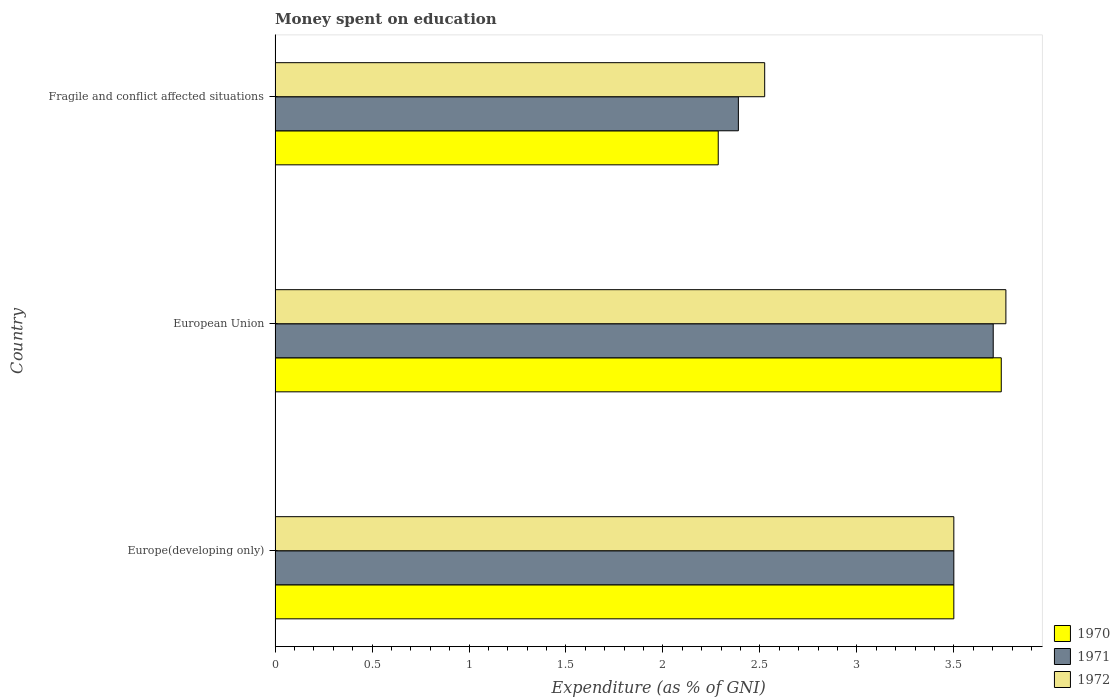How many different coloured bars are there?
Your answer should be compact. 3. How many groups of bars are there?
Your answer should be compact. 3. How many bars are there on the 1st tick from the top?
Give a very brief answer. 3. What is the label of the 1st group of bars from the top?
Give a very brief answer. Fragile and conflict affected situations. What is the amount of money spent on education in 1970 in European Union?
Ensure brevity in your answer.  3.74. Across all countries, what is the maximum amount of money spent on education in 1971?
Make the answer very short. 3.7. Across all countries, what is the minimum amount of money spent on education in 1970?
Offer a terse response. 2.29. In which country was the amount of money spent on education in 1970 maximum?
Your answer should be compact. European Union. In which country was the amount of money spent on education in 1972 minimum?
Provide a short and direct response. Fragile and conflict affected situations. What is the total amount of money spent on education in 1972 in the graph?
Your answer should be compact. 9.79. What is the difference between the amount of money spent on education in 1971 in European Union and that in Fragile and conflict affected situations?
Your answer should be very brief. 1.31. What is the difference between the amount of money spent on education in 1971 in European Union and the amount of money spent on education in 1972 in Fragile and conflict affected situations?
Your answer should be compact. 1.18. What is the average amount of money spent on education in 1972 per country?
Provide a succinct answer. 3.26. What is the difference between the amount of money spent on education in 1971 and amount of money spent on education in 1970 in Fragile and conflict affected situations?
Offer a terse response. 0.1. In how many countries, is the amount of money spent on education in 1970 greater than 3.6 %?
Provide a succinct answer. 1. What is the ratio of the amount of money spent on education in 1970 in European Union to that in Fragile and conflict affected situations?
Provide a succinct answer. 1.64. Is the amount of money spent on education in 1971 in Europe(developing only) less than that in European Union?
Your answer should be very brief. Yes. Is the difference between the amount of money spent on education in 1971 in Europe(developing only) and Fragile and conflict affected situations greater than the difference between the amount of money spent on education in 1970 in Europe(developing only) and Fragile and conflict affected situations?
Make the answer very short. No. What is the difference between the highest and the second highest amount of money spent on education in 1970?
Your response must be concise. 0.24. What is the difference between the highest and the lowest amount of money spent on education in 1971?
Ensure brevity in your answer.  1.31. What does the 3rd bar from the bottom in Fragile and conflict affected situations represents?
Ensure brevity in your answer.  1972. How many bars are there?
Keep it short and to the point. 9. Are all the bars in the graph horizontal?
Make the answer very short. Yes. How many countries are there in the graph?
Your answer should be very brief. 3. Are the values on the major ticks of X-axis written in scientific E-notation?
Keep it short and to the point. No. Where does the legend appear in the graph?
Offer a terse response. Bottom right. How many legend labels are there?
Give a very brief answer. 3. What is the title of the graph?
Provide a succinct answer. Money spent on education. What is the label or title of the X-axis?
Make the answer very short. Expenditure (as % of GNI). What is the Expenditure (as % of GNI) in 1972 in Europe(developing only)?
Offer a terse response. 3.5. What is the Expenditure (as % of GNI) of 1970 in European Union?
Provide a succinct answer. 3.74. What is the Expenditure (as % of GNI) in 1971 in European Union?
Give a very brief answer. 3.7. What is the Expenditure (as % of GNI) in 1972 in European Union?
Give a very brief answer. 3.77. What is the Expenditure (as % of GNI) in 1970 in Fragile and conflict affected situations?
Your answer should be very brief. 2.29. What is the Expenditure (as % of GNI) in 1971 in Fragile and conflict affected situations?
Offer a very short reply. 2.39. What is the Expenditure (as % of GNI) of 1972 in Fragile and conflict affected situations?
Your answer should be very brief. 2.52. Across all countries, what is the maximum Expenditure (as % of GNI) of 1970?
Offer a terse response. 3.74. Across all countries, what is the maximum Expenditure (as % of GNI) of 1971?
Your answer should be compact. 3.7. Across all countries, what is the maximum Expenditure (as % of GNI) in 1972?
Give a very brief answer. 3.77. Across all countries, what is the minimum Expenditure (as % of GNI) of 1970?
Keep it short and to the point. 2.29. Across all countries, what is the minimum Expenditure (as % of GNI) of 1971?
Your response must be concise. 2.39. Across all countries, what is the minimum Expenditure (as % of GNI) in 1972?
Keep it short and to the point. 2.52. What is the total Expenditure (as % of GNI) in 1970 in the graph?
Keep it short and to the point. 9.53. What is the total Expenditure (as % of GNI) in 1971 in the graph?
Your answer should be compact. 9.59. What is the total Expenditure (as % of GNI) in 1972 in the graph?
Ensure brevity in your answer.  9.79. What is the difference between the Expenditure (as % of GNI) of 1970 in Europe(developing only) and that in European Union?
Offer a terse response. -0.24. What is the difference between the Expenditure (as % of GNI) of 1971 in Europe(developing only) and that in European Union?
Your answer should be compact. -0.2. What is the difference between the Expenditure (as % of GNI) in 1972 in Europe(developing only) and that in European Union?
Give a very brief answer. -0.27. What is the difference between the Expenditure (as % of GNI) in 1970 in Europe(developing only) and that in Fragile and conflict affected situations?
Keep it short and to the point. 1.21. What is the difference between the Expenditure (as % of GNI) in 1971 in Europe(developing only) and that in Fragile and conflict affected situations?
Give a very brief answer. 1.11. What is the difference between the Expenditure (as % of GNI) of 1972 in Europe(developing only) and that in Fragile and conflict affected situations?
Ensure brevity in your answer.  0.98. What is the difference between the Expenditure (as % of GNI) in 1970 in European Union and that in Fragile and conflict affected situations?
Ensure brevity in your answer.  1.46. What is the difference between the Expenditure (as % of GNI) in 1971 in European Union and that in Fragile and conflict affected situations?
Offer a very short reply. 1.31. What is the difference between the Expenditure (as % of GNI) in 1972 in European Union and that in Fragile and conflict affected situations?
Your answer should be compact. 1.24. What is the difference between the Expenditure (as % of GNI) of 1970 in Europe(developing only) and the Expenditure (as % of GNI) of 1971 in European Union?
Your answer should be very brief. -0.2. What is the difference between the Expenditure (as % of GNI) of 1970 in Europe(developing only) and the Expenditure (as % of GNI) of 1972 in European Union?
Ensure brevity in your answer.  -0.27. What is the difference between the Expenditure (as % of GNI) of 1971 in Europe(developing only) and the Expenditure (as % of GNI) of 1972 in European Union?
Give a very brief answer. -0.27. What is the difference between the Expenditure (as % of GNI) in 1970 in Europe(developing only) and the Expenditure (as % of GNI) in 1971 in Fragile and conflict affected situations?
Ensure brevity in your answer.  1.11. What is the difference between the Expenditure (as % of GNI) of 1970 in Europe(developing only) and the Expenditure (as % of GNI) of 1972 in Fragile and conflict affected situations?
Your answer should be compact. 0.98. What is the difference between the Expenditure (as % of GNI) in 1971 in Europe(developing only) and the Expenditure (as % of GNI) in 1972 in Fragile and conflict affected situations?
Give a very brief answer. 0.98. What is the difference between the Expenditure (as % of GNI) of 1970 in European Union and the Expenditure (as % of GNI) of 1971 in Fragile and conflict affected situations?
Keep it short and to the point. 1.36. What is the difference between the Expenditure (as % of GNI) in 1970 in European Union and the Expenditure (as % of GNI) in 1972 in Fragile and conflict affected situations?
Make the answer very short. 1.22. What is the difference between the Expenditure (as % of GNI) of 1971 in European Union and the Expenditure (as % of GNI) of 1972 in Fragile and conflict affected situations?
Your response must be concise. 1.18. What is the average Expenditure (as % of GNI) in 1970 per country?
Provide a short and direct response. 3.18. What is the average Expenditure (as % of GNI) of 1971 per country?
Ensure brevity in your answer.  3.2. What is the average Expenditure (as % of GNI) in 1972 per country?
Your response must be concise. 3.26. What is the difference between the Expenditure (as % of GNI) of 1970 and Expenditure (as % of GNI) of 1972 in Europe(developing only)?
Your response must be concise. 0. What is the difference between the Expenditure (as % of GNI) in 1971 and Expenditure (as % of GNI) in 1972 in Europe(developing only)?
Offer a very short reply. 0. What is the difference between the Expenditure (as % of GNI) of 1970 and Expenditure (as % of GNI) of 1971 in European Union?
Your answer should be compact. 0.04. What is the difference between the Expenditure (as % of GNI) of 1970 and Expenditure (as % of GNI) of 1972 in European Union?
Ensure brevity in your answer.  -0.02. What is the difference between the Expenditure (as % of GNI) of 1971 and Expenditure (as % of GNI) of 1972 in European Union?
Make the answer very short. -0.07. What is the difference between the Expenditure (as % of GNI) in 1970 and Expenditure (as % of GNI) in 1971 in Fragile and conflict affected situations?
Your answer should be compact. -0.1. What is the difference between the Expenditure (as % of GNI) of 1970 and Expenditure (as % of GNI) of 1972 in Fragile and conflict affected situations?
Keep it short and to the point. -0.24. What is the difference between the Expenditure (as % of GNI) in 1971 and Expenditure (as % of GNI) in 1972 in Fragile and conflict affected situations?
Your response must be concise. -0.14. What is the ratio of the Expenditure (as % of GNI) in 1970 in Europe(developing only) to that in European Union?
Your response must be concise. 0.93. What is the ratio of the Expenditure (as % of GNI) of 1971 in Europe(developing only) to that in European Union?
Your answer should be compact. 0.95. What is the ratio of the Expenditure (as % of GNI) in 1972 in Europe(developing only) to that in European Union?
Offer a terse response. 0.93. What is the ratio of the Expenditure (as % of GNI) in 1970 in Europe(developing only) to that in Fragile and conflict affected situations?
Give a very brief answer. 1.53. What is the ratio of the Expenditure (as % of GNI) of 1971 in Europe(developing only) to that in Fragile and conflict affected situations?
Provide a short and direct response. 1.47. What is the ratio of the Expenditure (as % of GNI) of 1972 in Europe(developing only) to that in Fragile and conflict affected situations?
Make the answer very short. 1.39. What is the ratio of the Expenditure (as % of GNI) of 1970 in European Union to that in Fragile and conflict affected situations?
Keep it short and to the point. 1.64. What is the ratio of the Expenditure (as % of GNI) in 1971 in European Union to that in Fragile and conflict affected situations?
Offer a terse response. 1.55. What is the ratio of the Expenditure (as % of GNI) of 1972 in European Union to that in Fragile and conflict affected situations?
Your answer should be compact. 1.49. What is the difference between the highest and the second highest Expenditure (as % of GNI) of 1970?
Your response must be concise. 0.24. What is the difference between the highest and the second highest Expenditure (as % of GNI) of 1971?
Ensure brevity in your answer.  0.2. What is the difference between the highest and the second highest Expenditure (as % of GNI) of 1972?
Provide a short and direct response. 0.27. What is the difference between the highest and the lowest Expenditure (as % of GNI) of 1970?
Provide a succinct answer. 1.46. What is the difference between the highest and the lowest Expenditure (as % of GNI) in 1971?
Ensure brevity in your answer.  1.31. What is the difference between the highest and the lowest Expenditure (as % of GNI) in 1972?
Your answer should be very brief. 1.24. 